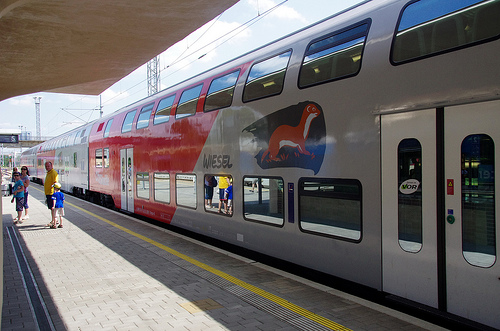Describe any artwork visible on the train. The train sports an artistic portrayal of a red weasel, which adds a splash of color and creativity to its otherwise utilitarian appearance. What might this choice of artwork signify? The weasel could symbolize agility and speed, characteristics desirable in train travel, perhaps echoing the train's efficiency in transporting passengers swiftly. 